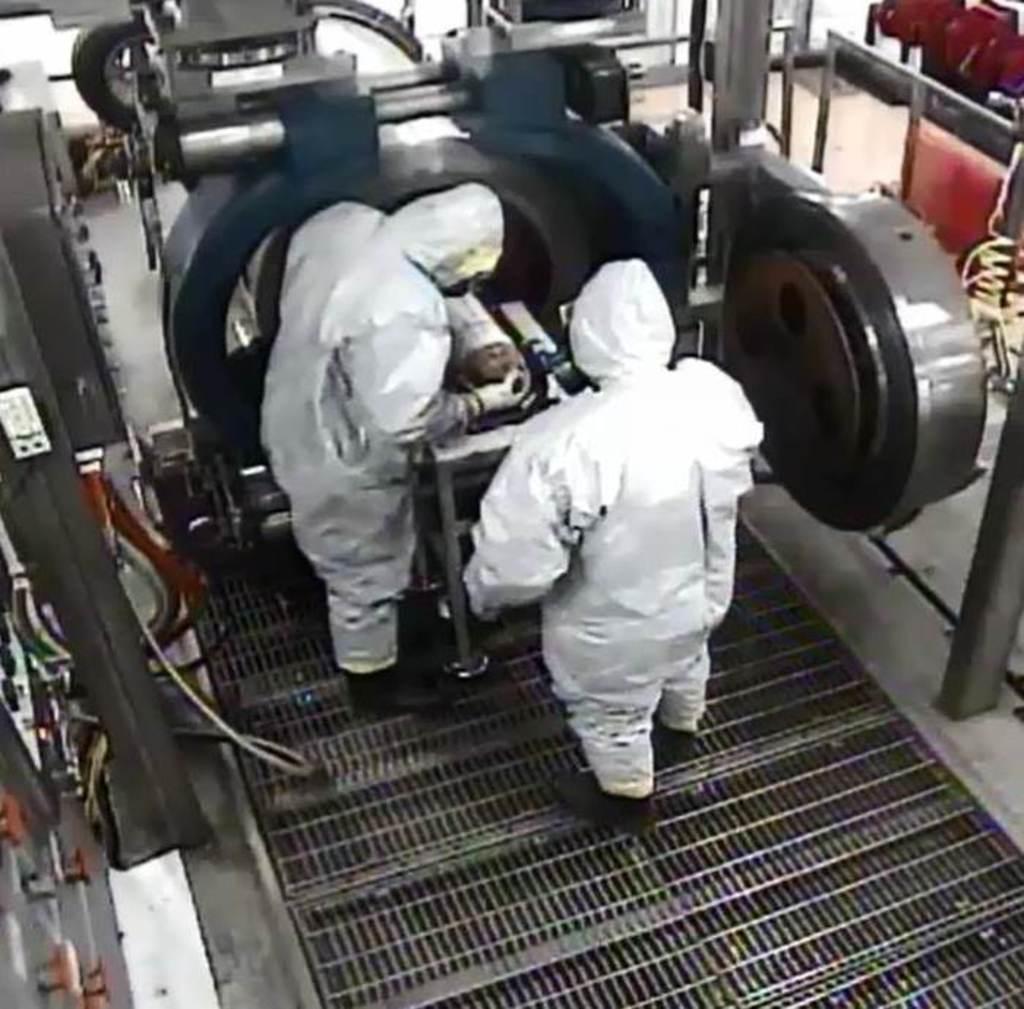In one or two sentences, can you explain what this image depicts? In the center of the image we can see two people working. There are machines. At the bottom we can see a mesh. 